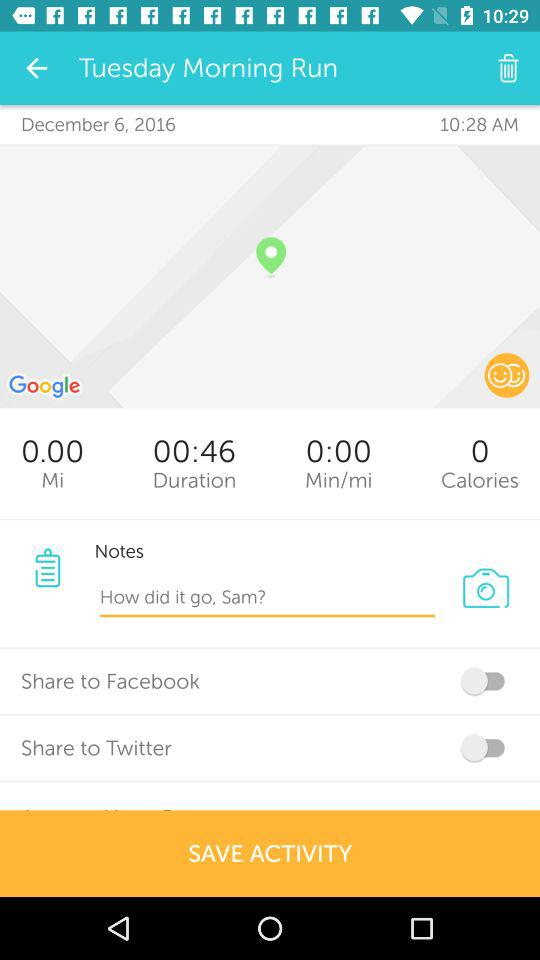What is the running duration? The running duration is 46 seconds. 